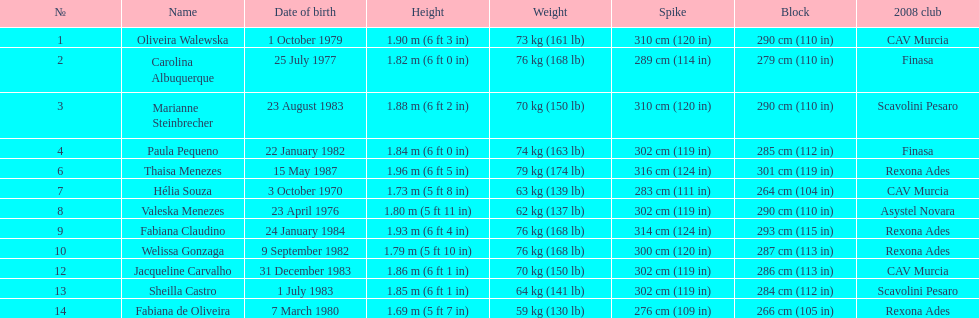Oliveira walewska has the same block as how many other players? 2. 